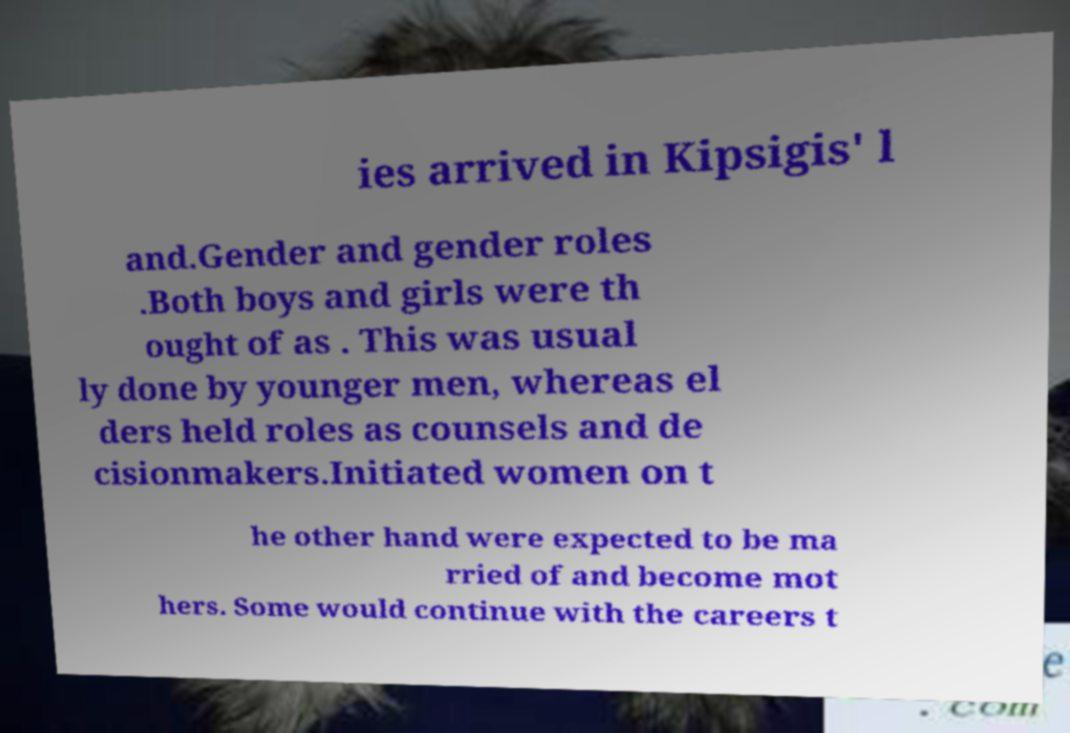What messages or text are displayed in this image? I need them in a readable, typed format. ies arrived in Kipsigis' l and.Gender and gender roles .Both boys and girls were th ought of as . This was usual ly done by younger men, whereas el ders held roles as counsels and de cisionmakers.Initiated women on t he other hand were expected to be ma rried of and become mot hers. Some would continue with the careers t 